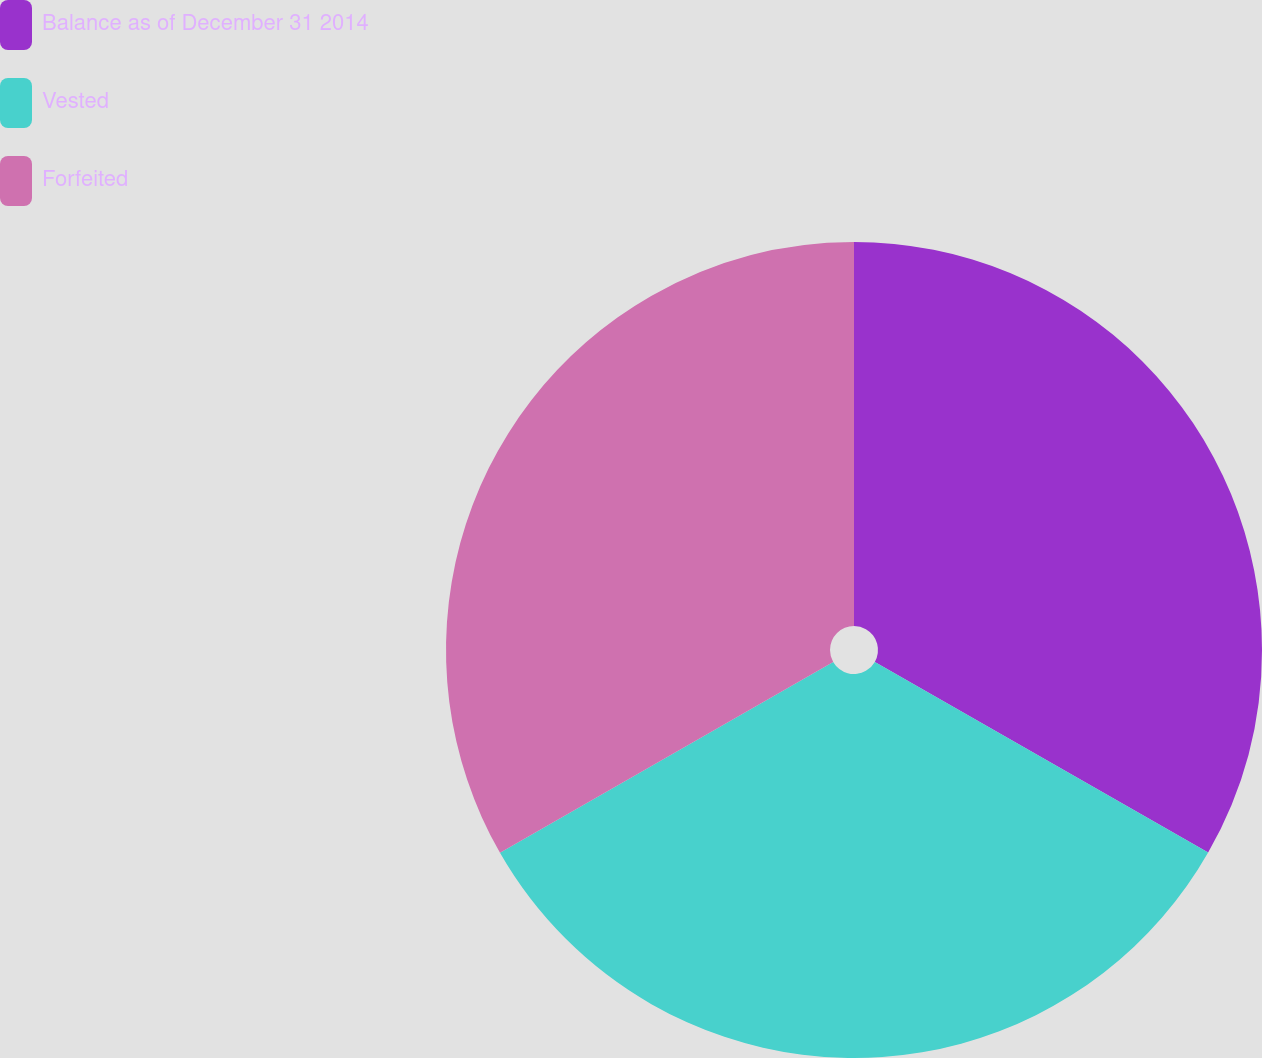Convert chart to OTSL. <chart><loc_0><loc_0><loc_500><loc_500><pie_chart><fcel>Balance as of December 31 2014<fcel>Vested<fcel>Forfeited<nl><fcel>33.27%<fcel>33.45%<fcel>33.28%<nl></chart> 